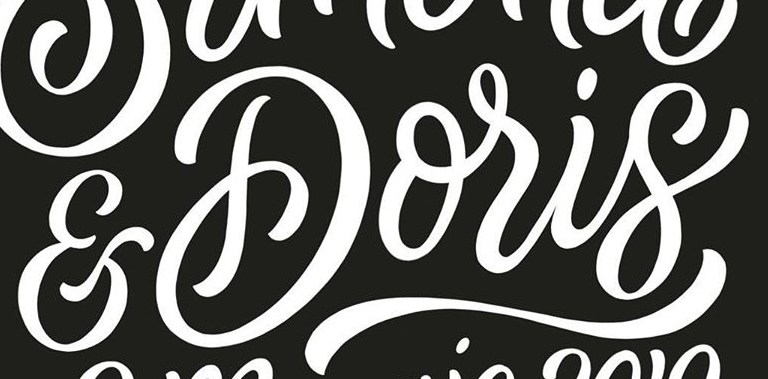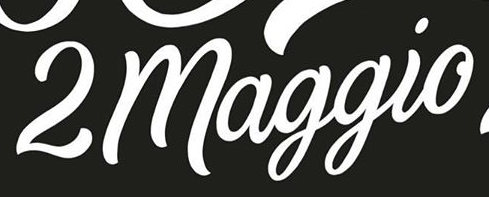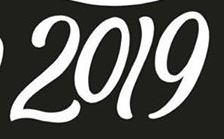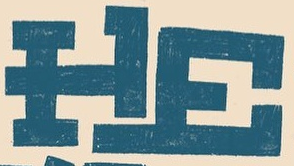What text is displayed in these images sequentially, separated by a semicolon? &Doris; 2maggio; 2019; HE 